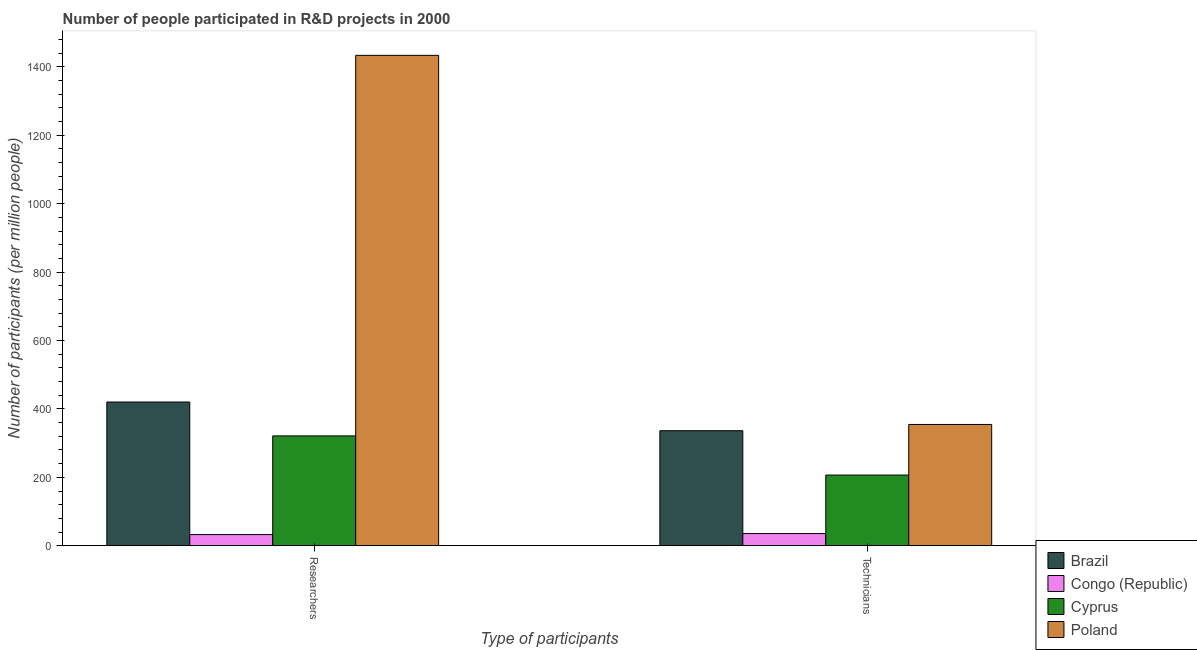How many groups of bars are there?
Provide a short and direct response. 2. Are the number of bars on each tick of the X-axis equal?
Your response must be concise. Yes. How many bars are there on the 2nd tick from the left?
Provide a succinct answer. 4. How many bars are there on the 1st tick from the right?
Provide a succinct answer. 4. What is the label of the 1st group of bars from the left?
Your response must be concise. Researchers. What is the number of technicians in Brazil?
Your response must be concise. 336.36. Across all countries, what is the maximum number of researchers?
Provide a short and direct response. 1433.6. Across all countries, what is the minimum number of researchers?
Offer a terse response. 32.72. In which country was the number of technicians minimum?
Offer a very short reply. Congo (Republic). What is the total number of researchers in the graph?
Offer a terse response. 2207.8. What is the difference between the number of technicians in Cyprus and that in Poland?
Your answer should be very brief. -147.9. What is the difference between the number of technicians in Cyprus and the number of researchers in Congo (Republic)?
Keep it short and to the point. 174. What is the average number of technicians per country?
Your answer should be compact. 233.35. What is the difference between the number of researchers and number of technicians in Poland?
Offer a very short reply. 1078.98. What is the ratio of the number of researchers in Poland to that in Brazil?
Your response must be concise. 3.41. Is the number of technicians in Brazil less than that in Congo (Republic)?
Give a very brief answer. No. What does the 3rd bar from the left in Researchers represents?
Provide a succinct answer. Cyprus. Are all the bars in the graph horizontal?
Your response must be concise. No. How many countries are there in the graph?
Offer a very short reply. 4. What is the difference between two consecutive major ticks on the Y-axis?
Your answer should be very brief. 200. Are the values on the major ticks of Y-axis written in scientific E-notation?
Your answer should be very brief. No. Where does the legend appear in the graph?
Ensure brevity in your answer.  Bottom right. What is the title of the graph?
Your response must be concise. Number of people participated in R&D projects in 2000. What is the label or title of the X-axis?
Ensure brevity in your answer.  Type of participants. What is the label or title of the Y-axis?
Your response must be concise. Number of participants (per million people). What is the Number of participants (per million people) of Brazil in Researchers?
Give a very brief answer. 420.25. What is the Number of participants (per million people) of Congo (Republic) in Researchers?
Offer a very short reply. 32.72. What is the Number of participants (per million people) in Cyprus in Researchers?
Provide a succinct answer. 321.22. What is the Number of participants (per million people) in Poland in Researchers?
Make the answer very short. 1433.6. What is the Number of participants (per million people) of Brazil in Technicians?
Your answer should be compact. 336.36. What is the Number of participants (per million people) of Congo (Republic) in Technicians?
Offer a very short reply. 35.7. What is the Number of participants (per million people) of Cyprus in Technicians?
Offer a very short reply. 206.72. What is the Number of participants (per million people) in Poland in Technicians?
Give a very brief answer. 354.62. Across all Type of participants, what is the maximum Number of participants (per million people) in Brazil?
Give a very brief answer. 420.25. Across all Type of participants, what is the maximum Number of participants (per million people) of Congo (Republic)?
Your answer should be very brief. 35.7. Across all Type of participants, what is the maximum Number of participants (per million people) in Cyprus?
Keep it short and to the point. 321.22. Across all Type of participants, what is the maximum Number of participants (per million people) of Poland?
Provide a succinct answer. 1433.6. Across all Type of participants, what is the minimum Number of participants (per million people) in Brazil?
Your answer should be very brief. 336.36. Across all Type of participants, what is the minimum Number of participants (per million people) in Congo (Republic)?
Provide a succinct answer. 32.72. Across all Type of participants, what is the minimum Number of participants (per million people) in Cyprus?
Offer a very short reply. 206.72. Across all Type of participants, what is the minimum Number of participants (per million people) in Poland?
Offer a very short reply. 354.62. What is the total Number of participants (per million people) in Brazil in the graph?
Your answer should be very brief. 756.61. What is the total Number of participants (per million people) in Congo (Republic) in the graph?
Ensure brevity in your answer.  68.42. What is the total Number of participants (per million people) in Cyprus in the graph?
Provide a short and direct response. 527.94. What is the total Number of participants (per million people) in Poland in the graph?
Keep it short and to the point. 1788.22. What is the difference between the Number of participants (per million people) in Brazil in Researchers and that in Technicians?
Provide a succinct answer. 83.9. What is the difference between the Number of participants (per million people) in Congo (Republic) in Researchers and that in Technicians?
Ensure brevity in your answer.  -2.98. What is the difference between the Number of participants (per million people) of Cyprus in Researchers and that in Technicians?
Provide a short and direct response. 114.49. What is the difference between the Number of participants (per million people) in Poland in Researchers and that in Technicians?
Offer a terse response. 1078.98. What is the difference between the Number of participants (per million people) in Brazil in Researchers and the Number of participants (per million people) in Congo (Republic) in Technicians?
Provide a short and direct response. 384.55. What is the difference between the Number of participants (per million people) of Brazil in Researchers and the Number of participants (per million people) of Cyprus in Technicians?
Offer a very short reply. 213.53. What is the difference between the Number of participants (per million people) of Brazil in Researchers and the Number of participants (per million people) of Poland in Technicians?
Provide a succinct answer. 65.63. What is the difference between the Number of participants (per million people) in Congo (Republic) in Researchers and the Number of participants (per million people) in Cyprus in Technicians?
Ensure brevity in your answer.  -174. What is the difference between the Number of participants (per million people) of Congo (Republic) in Researchers and the Number of participants (per million people) of Poland in Technicians?
Ensure brevity in your answer.  -321.89. What is the difference between the Number of participants (per million people) in Cyprus in Researchers and the Number of participants (per million people) in Poland in Technicians?
Provide a succinct answer. -33.4. What is the average Number of participants (per million people) of Brazil per Type of participants?
Make the answer very short. 378.31. What is the average Number of participants (per million people) in Congo (Republic) per Type of participants?
Give a very brief answer. 34.21. What is the average Number of participants (per million people) in Cyprus per Type of participants?
Give a very brief answer. 263.97. What is the average Number of participants (per million people) of Poland per Type of participants?
Provide a short and direct response. 894.11. What is the difference between the Number of participants (per million people) in Brazil and Number of participants (per million people) in Congo (Republic) in Researchers?
Your answer should be very brief. 387.53. What is the difference between the Number of participants (per million people) in Brazil and Number of participants (per million people) in Cyprus in Researchers?
Your answer should be very brief. 99.04. What is the difference between the Number of participants (per million people) of Brazil and Number of participants (per million people) of Poland in Researchers?
Provide a short and direct response. -1013.35. What is the difference between the Number of participants (per million people) of Congo (Republic) and Number of participants (per million people) of Cyprus in Researchers?
Your response must be concise. -288.49. What is the difference between the Number of participants (per million people) in Congo (Republic) and Number of participants (per million people) in Poland in Researchers?
Ensure brevity in your answer.  -1400.88. What is the difference between the Number of participants (per million people) in Cyprus and Number of participants (per million people) in Poland in Researchers?
Offer a terse response. -1112.38. What is the difference between the Number of participants (per million people) in Brazil and Number of participants (per million people) in Congo (Republic) in Technicians?
Your answer should be very brief. 300.66. What is the difference between the Number of participants (per million people) of Brazil and Number of participants (per million people) of Cyprus in Technicians?
Your answer should be compact. 129.63. What is the difference between the Number of participants (per million people) in Brazil and Number of participants (per million people) in Poland in Technicians?
Offer a very short reply. -18.26. What is the difference between the Number of participants (per million people) in Congo (Republic) and Number of participants (per million people) in Cyprus in Technicians?
Your answer should be compact. -171.02. What is the difference between the Number of participants (per million people) of Congo (Republic) and Number of participants (per million people) of Poland in Technicians?
Offer a very short reply. -318.92. What is the difference between the Number of participants (per million people) in Cyprus and Number of participants (per million people) in Poland in Technicians?
Your answer should be compact. -147.9. What is the ratio of the Number of participants (per million people) of Brazil in Researchers to that in Technicians?
Your response must be concise. 1.25. What is the ratio of the Number of participants (per million people) of Cyprus in Researchers to that in Technicians?
Offer a very short reply. 1.55. What is the ratio of the Number of participants (per million people) in Poland in Researchers to that in Technicians?
Give a very brief answer. 4.04. What is the difference between the highest and the second highest Number of participants (per million people) of Brazil?
Your answer should be very brief. 83.9. What is the difference between the highest and the second highest Number of participants (per million people) in Congo (Republic)?
Provide a succinct answer. 2.98. What is the difference between the highest and the second highest Number of participants (per million people) of Cyprus?
Your answer should be very brief. 114.49. What is the difference between the highest and the second highest Number of participants (per million people) in Poland?
Offer a terse response. 1078.98. What is the difference between the highest and the lowest Number of participants (per million people) of Brazil?
Your response must be concise. 83.9. What is the difference between the highest and the lowest Number of participants (per million people) of Congo (Republic)?
Give a very brief answer. 2.98. What is the difference between the highest and the lowest Number of participants (per million people) in Cyprus?
Keep it short and to the point. 114.49. What is the difference between the highest and the lowest Number of participants (per million people) in Poland?
Make the answer very short. 1078.98. 